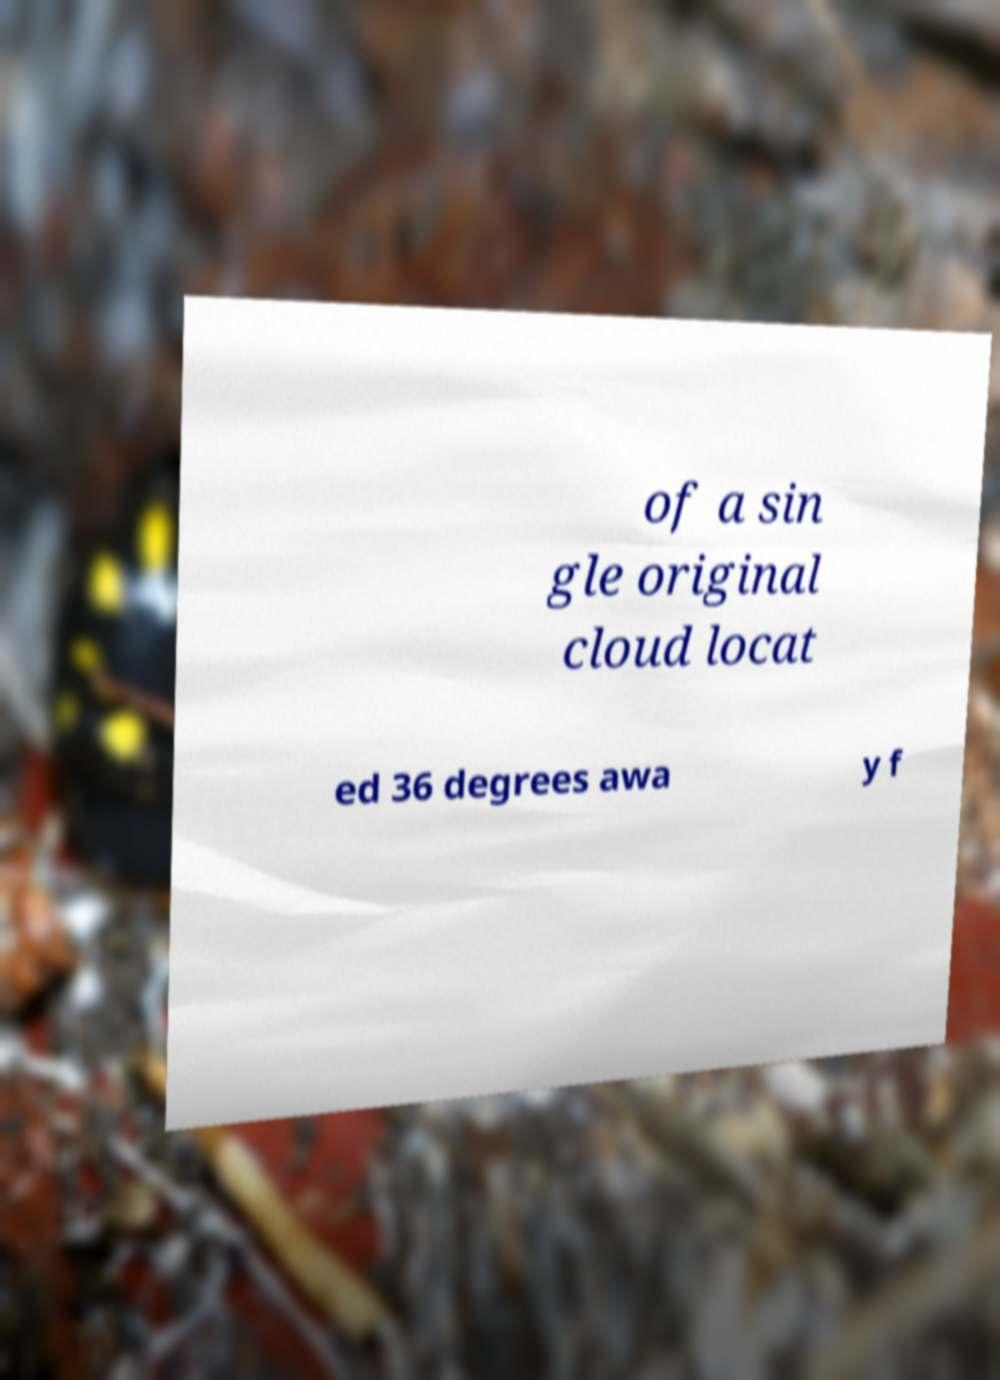Please identify and transcribe the text found in this image. of a sin gle original cloud locat ed 36 degrees awa y f 